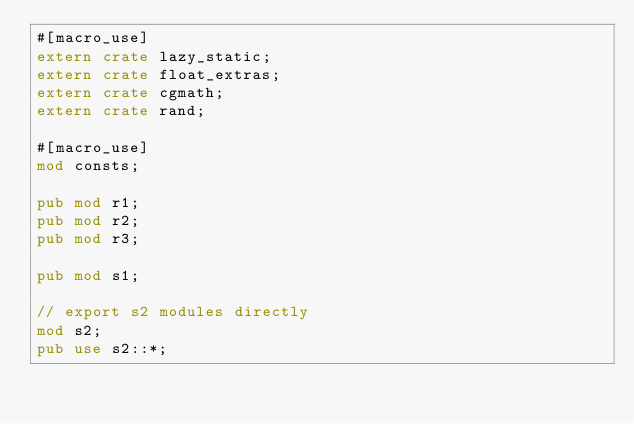Convert code to text. <code><loc_0><loc_0><loc_500><loc_500><_Rust_>#[macro_use]
extern crate lazy_static;
extern crate float_extras;
extern crate cgmath;
extern crate rand;

#[macro_use]
mod consts;

pub mod r1;
pub mod r2;
pub mod r3;

pub mod s1;

// export s2 modules directly
mod s2;
pub use s2::*;
</code> 